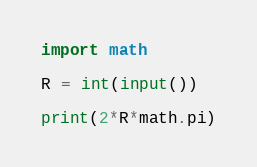<code> <loc_0><loc_0><loc_500><loc_500><_Python_>import math
 
R = int(input())
 
print(2*R*math.pi)
</code> 